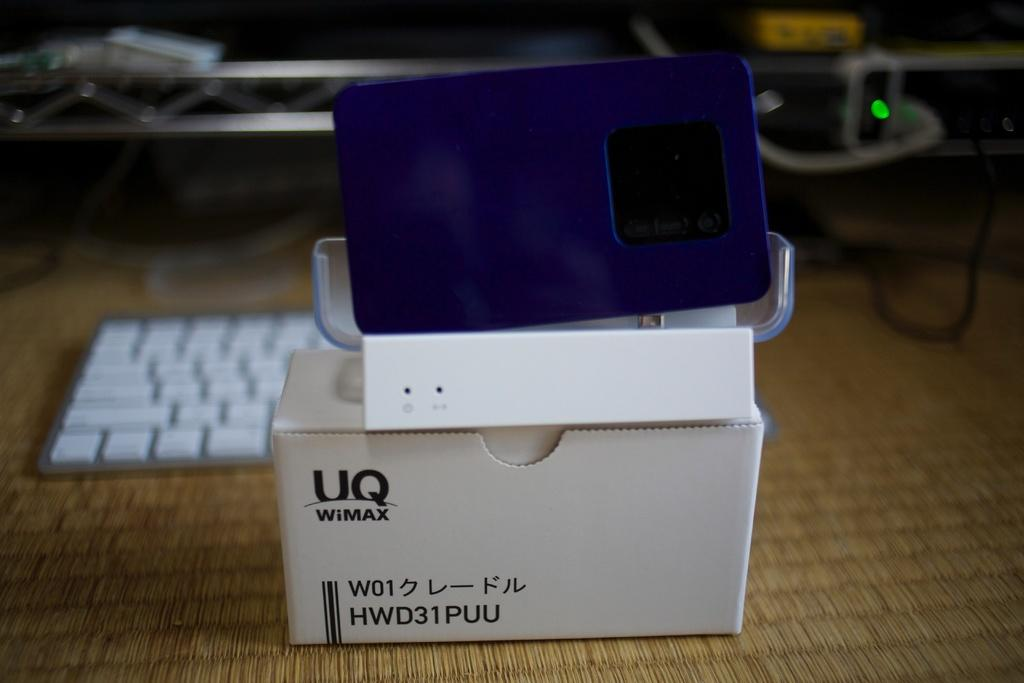<image>
Write a terse but informative summary of the picture. a small white box that is labeled as 'uq wimax' 